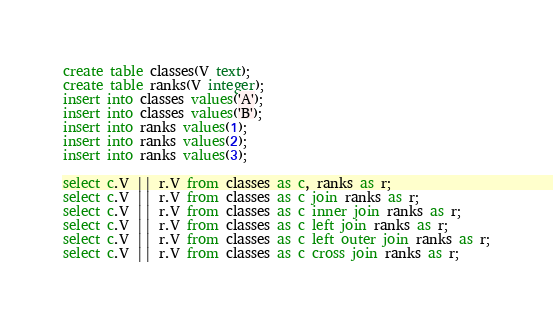Convert code to text. <code><loc_0><loc_0><loc_500><loc_500><_SQL_>create table classes(V text);
create table ranks(V integer);
insert into classes values('A');
insert into classes values('B');
insert into ranks values(1);
insert into ranks values(2);
insert into ranks values(3);

select c.V || r.V from classes as c, ranks as r;
select c.V || r.V from classes as c join ranks as r;
select c.V || r.V from classes as c inner join ranks as r;
select c.V || r.V from classes as c left join ranks as r;
select c.V || r.V from classes as c left outer join ranks as r;
select c.V || r.V from classes as c cross join ranks as r;

</code> 